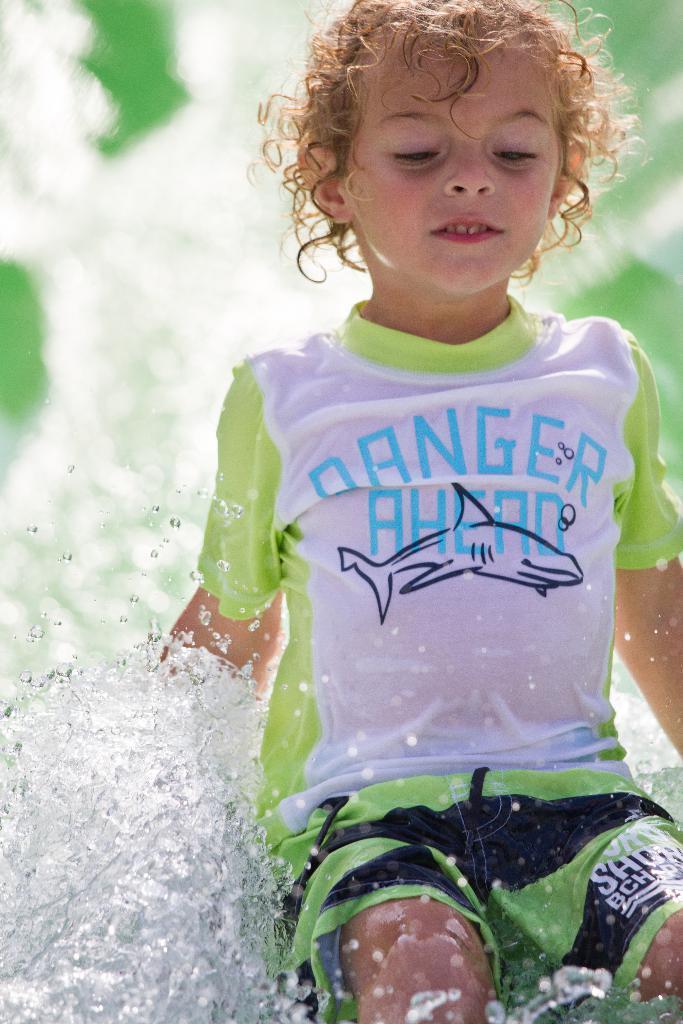How would you summarize this image in a sentence or two? In this image I see a child and I see that child is wearing white, green and black color dress and I see something is written over here and I see the depiction picture of fish and I see the water and I see that it is blurred in the background. 